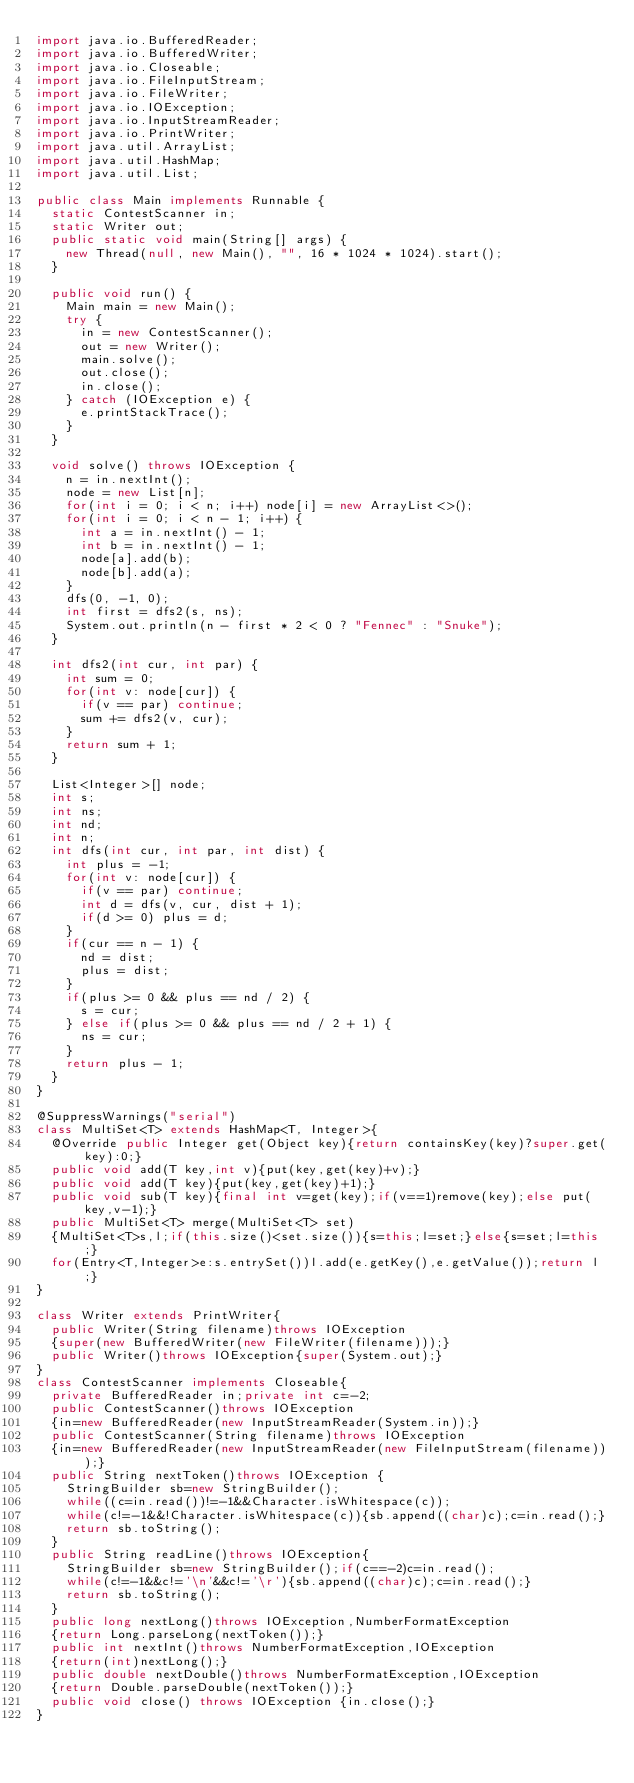<code> <loc_0><loc_0><loc_500><loc_500><_Java_>import java.io.BufferedReader;
import java.io.BufferedWriter;
import java.io.Closeable;
import java.io.FileInputStream;
import java.io.FileWriter;
import java.io.IOException;
import java.io.InputStreamReader;
import java.io.PrintWriter;
import java.util.ArrayList;
import java.util.HashMap;
import java.util.List;

public class Main implements Runnable {
	static ContestScanner in;
	static Writer out;
	public static void main(String[] args) {
		new Thread(null, new Main(), "", 16 * 1024 * 1024).start();
	}
	
	public void run() {
		Main main = new Main();
		try {
			in = new ContestScanner();
			out = new Writer();
			main.solve();
			out.close();
			in.close();
		} catch (IOException e) {
			e.printStackTrace();
		}
	}
	
	void solve() throws IOException {
		n = in.nextInt();
		node = new List[n];
		for(int i = 0; i < n; i++) node[i] = new ArrayList<>();
		for(int i = 0; i < n - 1; i++) {
			int a = in.nextInt() - 1;
			int b = in.nextInt() - 1;
			node[a].add(b);
			node[b].add(a);
		}
		dfs(0, -1, 0);
		int first = dfs2(s, ns);
		System.out.println(n - first * 2 < 0 ? "Fennec" : "Snuke");
	}
	
	int dfs2(int cur, int par) {
		int sum = 0;
		for(int v: node[cur]) {
			if(v == par) continue;
			sum += dfs2(v, cur);
		}
		return sum + 1;
	}
	
	List<Integer>[] node;
	int s;
	int ns;
	int nd;
	int n;
	int dfs(int cur, int par, int dist) {
		int plus = -1;
		for(int v: node[cur]) {
			if(v == par) continue;
			int d = dfs(v, cur, dist + 1);
			if(d >= 0) plus = d;
		}
		if(cur == n - 1) {
			nd = dist;
			plus = dist;
		}
		if(plus >= 0 && plus == nd / 2) {
			s = cur;
		} else if(plus >= 0 && plus == nd / 2 + 1) {
			ns = cur;
		}
		return plus - 1;
	}
}

@SuppressWarnings("serial")
class MultiSet<T> extends HashMap<T, Integer>{
	@Override public Integer get(Object key){return containsKey(key)?super.get(key):0;}
	public void add(T key,int v){put(key,get(key)+v);}
	public void add(T key){put(key,get(key)+1);}
	public void sub(T key){final int v=get(key);if(v==1)remove(key);else put(key,v-1);}
	public MultiSet<T> merge(MultiSet<T> set)
	{MultiSet<T>s,l;if(this.size()<set.size()){s=this;l=set;}else{s=set;l=this;}
	for(Entry<T,Integer>e:s.entrySet())l.add(e.getKey(),e.getValue());return l;}
}

class Writer extends PrintWriter{
	public Writer(String filename)throws IOException
	{super(new BufferedWriter(new FileWriter(filename)));}
	public Writer()throws IOException{super(System.out);}
}
class ContestScanner implements Closeable{
	private BufferedReader in;private int c=-2;
	public ContestScanner()throws IOException 
	{in=new BufferedReader(new InputStreamReader(System.in));}
	public ContestScanner(String filename)throws IOException
	{in=new BufferedReader(new InputStreamReader(new FileInputStream(filename)));}
	public String nextToken()throws IOException {
		StringBuilder sb=new StringBuilder();
		while((c=in.read())!=-1&&Character.isWhitespace(c));
		while(c!=-1&&!Character.isWhitespace(c)){sb.append((char)c);c=in.read();}
		return sb.toString();
	}
	public String readLine()throws IOException{
		StringBuilder sb=new StringBuilder();if(c==-2)c=in.read();
		while(c!=-1&&c!='\n'&&c!='\r'){sb.append((char)c);c=in.read();}
		return sb.toString();
	}
	public long nextLong()throws IOException,NumberFormatException
	{return Long.parseLong(nextToken());}
	public int nextInt()throws NumberFormatException,IOException
	{return(int)nextLong();}
	public double nextDouble()throws NumberFormatException,IOException 
	{return Double.parseDouble(nextToken());}
	public void close() throws IOException {in.close();}
}</code> 